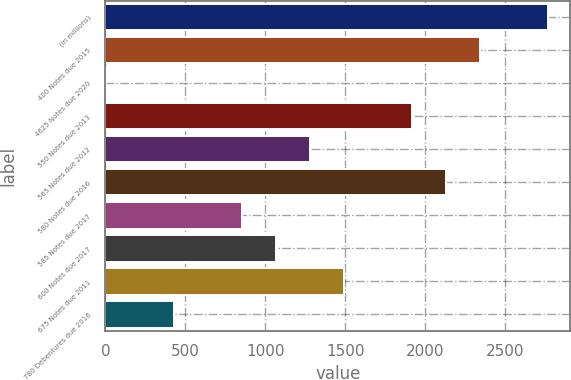<chart> <loc_0><loc_0><loc_500><loc_500><bar_chart><fcel>(in millions)<fcel>400 Notes due 2015<fcel>4625 Notes due 2020<fcel>550 Notes due 2013<fcel>565 Notes due 2012<fcel>580 Notes due 2016<fcel>585 Notes due 2017<fcel>600 Notes due 2017<fcel>675 Notes due 2011<fcel>780 Debentures due 2016<nl><fcel>2766.84<fcel>2341.82<fcel>4.21<fcel>1916.8<fcel>1279.27<fcel>2129.31<fcel>854.25<fcel>1066.76<fcel>1491.78<fcel>429.23<nl></chart> 